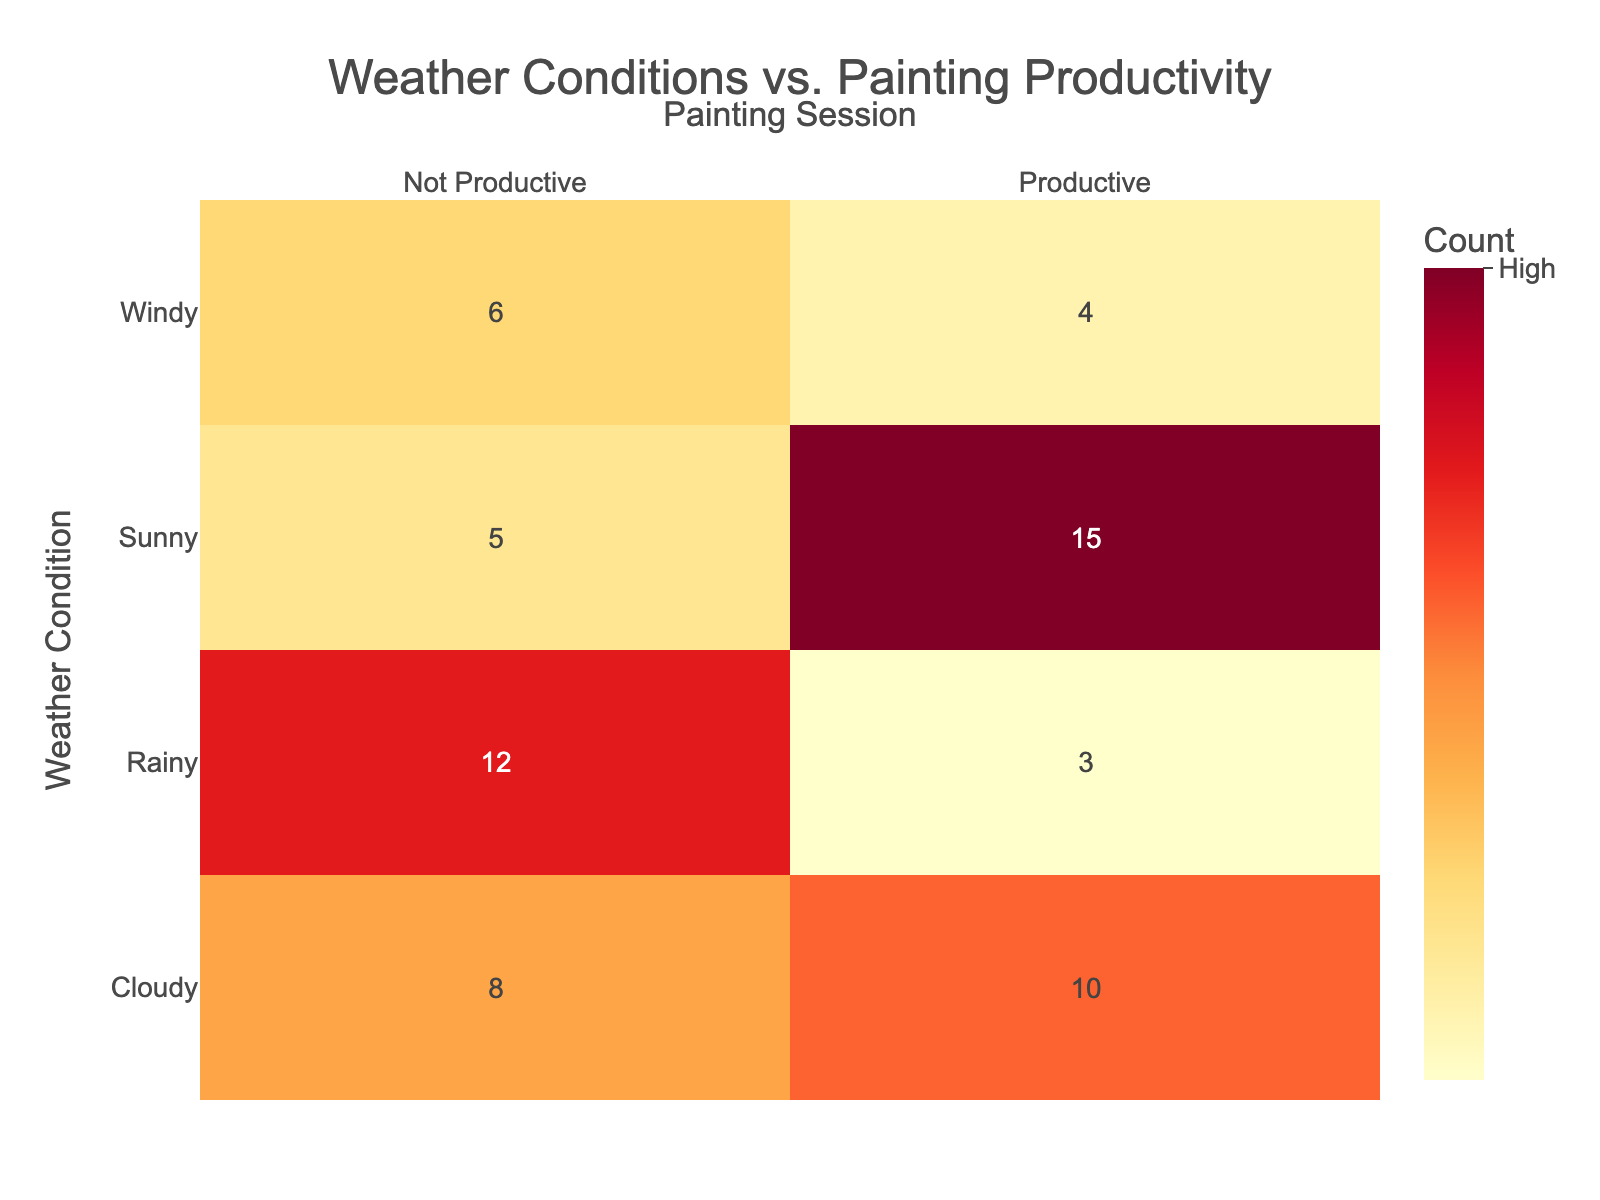What's the count of productive painting sessions on sunny days? According to the table, the count for productive painting sessions under sunny weather is listed directly as 15.
Answer: 15 What is the total count of not productive painting sessions across all weather conditions? The counts for not productive sessions are 5 (sunny) + 12 (rainy) + 8 (cloudy) + 6 (windy) = 31.
Answer: 31 Did I have more productive painting sessions on cloudy days than windy days? The counts for productive sessions are 10 (cloudy) and 4 (windy). Since 10 is greater than 4, the answer is yes.
Answer: Yes What is the sum of productive sessions on rainy and windy days? The productive sessions on rainy days total 3, and on windy days, they total 4. Summing these gives 3 + 4 = 7.
Answer: 7 Is there a greater number of not productive sessions on rainy days compared to sunny days? The not productive counts are 12 for rainy and 5 for sunny. Since 12 is greater than 5, the answer is yes.
Answer: Yes What is the average number of productive painting sessions across all weather conditions? There are four weather conditions with productive sessions: 15 (sunny) + 3 (rainy) + 10 (cloudy) + 4 (windy) = 32. With 4 conditions, the average is 32 / 4 = 8.
Answer: 8 Which weather condition had the highest count of not productive sessions? The counts of not productive sessions are 5 (sunny), 12 (rainy), 8 (cloudy), and 6 (windy). The highest count of 12 occurs on rainy days.
Answer: Rainy What is the difference in productive sessions between sunny and cloudy conditions? The productive sessions are 15 for sunny and 10 for cloudy. The difference is 15 - 10 = 5.
Answer: 5 If I want to know the overall productive sessions, how many do I have for all conditions combined? By adding the productive counts, we have 15 (sunny) + 3 (rainy) + 10 (cloudy) + 4 (windy) = 32.
Answer: 32 